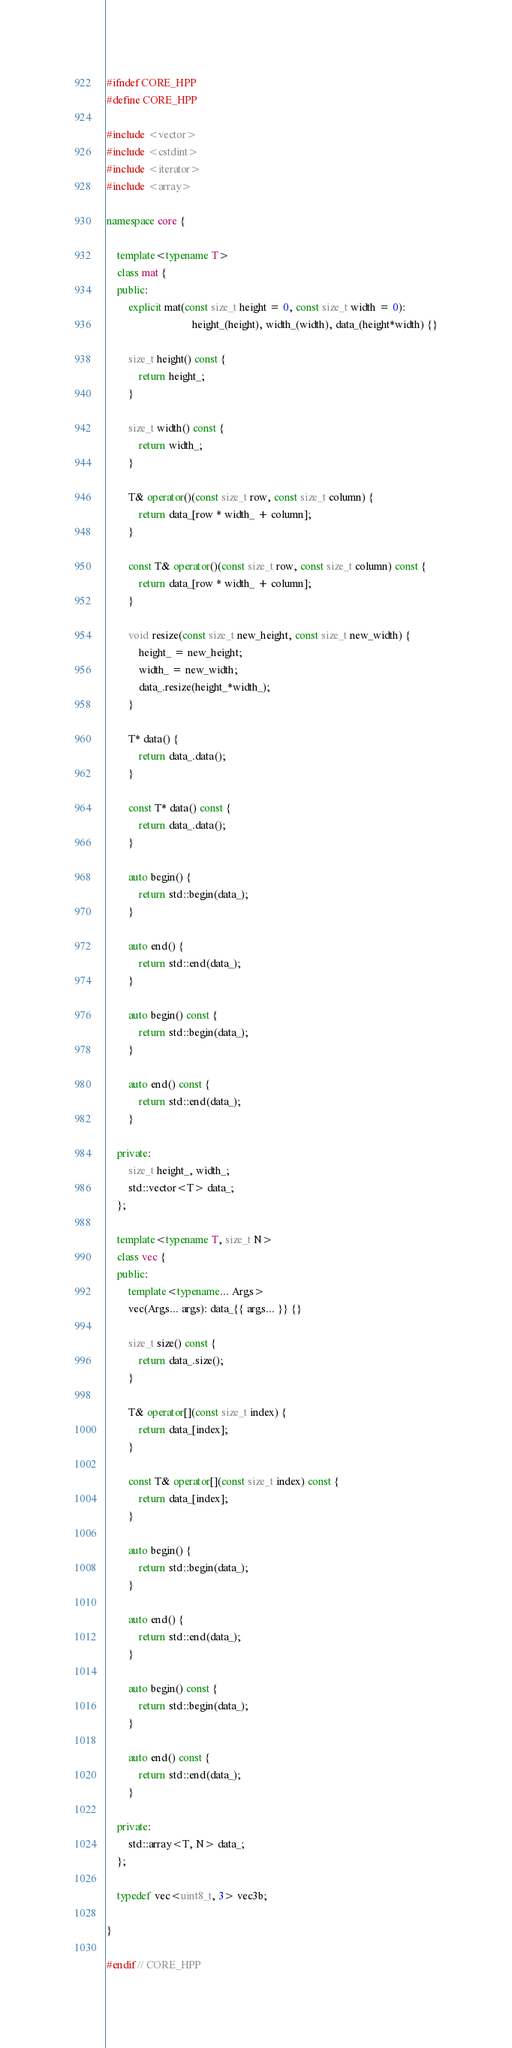Convert code to text. <code><loc_0><loc_0><loc_500><loc_500><_C++_>#ifndef CORE_HPP
#define CORE_HPP

#include <vector>
#include <cstdint>
#include <iterator>
#include <array>

namespace core {
	
	template<typename T>
	class mat {
	public:
		explicit mat(const size_t height = 0, const size_t width = 0):
								height_(height), width_(width), data_(height*width) {}

		size_t height() const {
			return height_;
		}

		size_t width() const {
			return width_;
		}

		T& operator()(const size_t row, const size_t column) {
			return data_[row * width_ + column];
		}

		const T& operator()(const size_t row, const size_t column) const {
			return data_[row * width_ + column];
		}

		void resize(const size_t new_height, const size_t new_width) {
			height_ = new_height;
			width_ = new_width;
			data_.resize(height_*width_);
		}

		T* data() {
			return data_.data();
		}

		const T* data() const {
			return data_.data();
		}

		auto begin() {
			return std::begin(data_);
		}

		auto end() {
			return std::end(data_);
		}

		auto begin() const {
			return std::begin(data_);
		}

		auto end() const {
			return std::end(data_);
		}

	private:
		size_t height_, width_;
		std::vector<T> data_;
	};

	template<typename T, size_t N>
	class vec {
	public:
		template<typename... Args>
		vec(Args... args): data_{{ args... }} {}

		size_t size() const {
			return data_.size();
		}

		T& operator[](const size_t index) {
			return data_[index];
		}

		const T& operator[](const size_t index) const {
			return data_[index];
		}

		auto begin() {
			return std::begin(data_);
		}

		auto end() {
			return std::end(data_);
		}

		auto begin() const {
			return std::begin(data_);
		}

		auto end() const {
			return std::end(data_);
		}

	private:
		std::array<T, N> data_;
	};

	typedef vec<uint8_t, 3> vec3b;

}

#endif // CORE_HPP</code> 